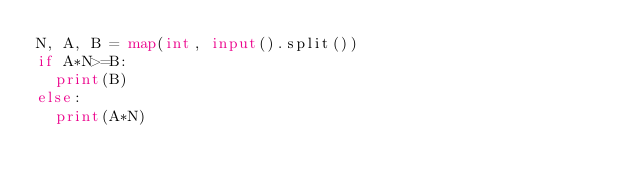Convert code to text. <code><loc_0><loc_0><loc_500><loc_500><_Python_>N, A, B = map(int, input().split())
if A*N>=B:
  print(B)
else:
  print(A*N)</code> 